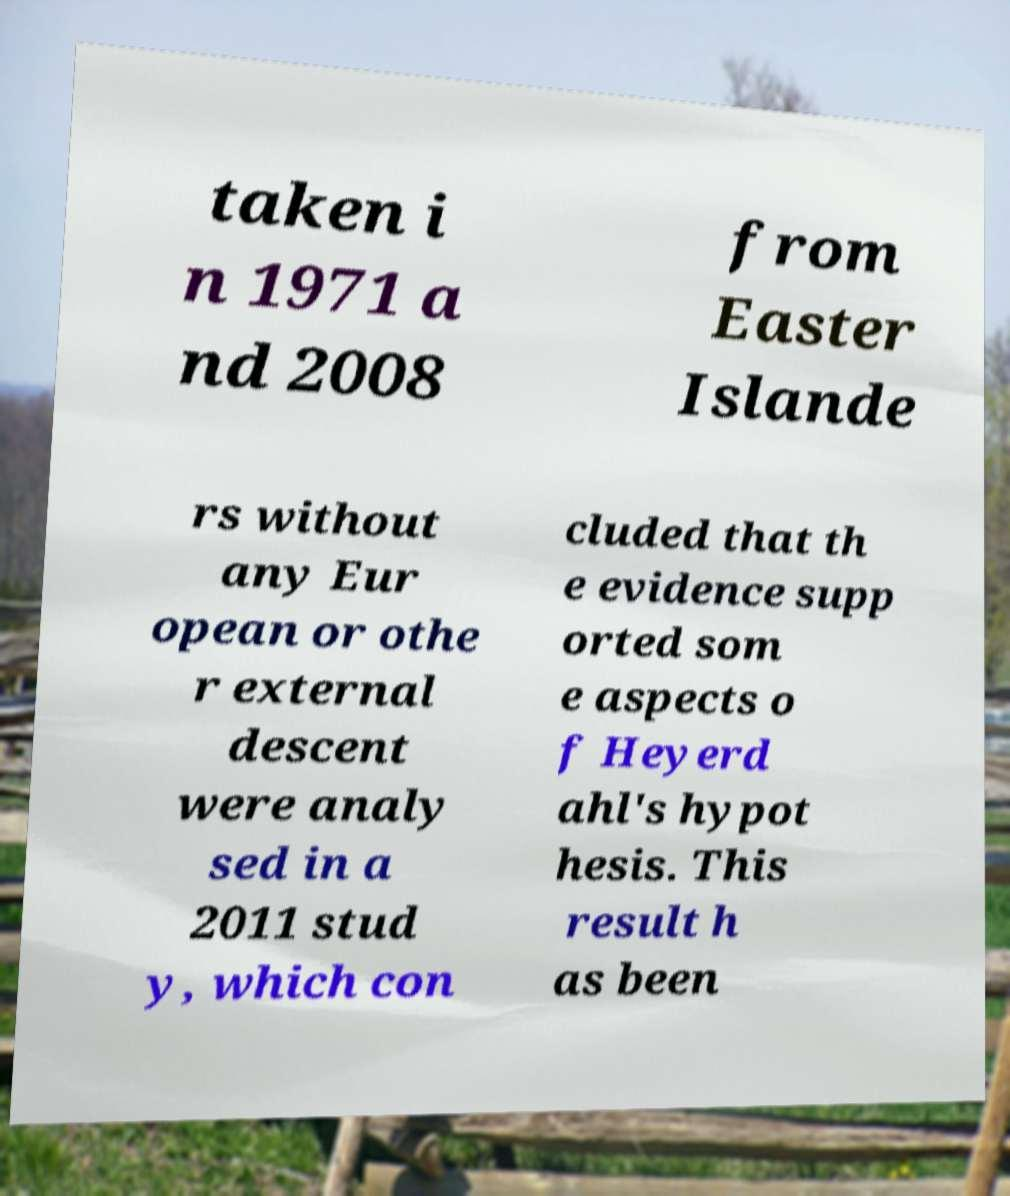Could you assist in decoding the text presented in this image and type it out clearly? taken i n 1971 a nd 2008 from Easter Islande rs without any Eur opean or othe r external descent were analy sed in a 2011 stud y, which con cluded that th e evidence supp orted som e aspects o f Heyerd ahl's hypot hesis. This result h as been 